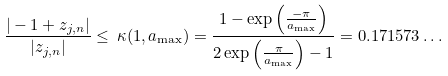Convert formula to latex. <formula><loc_0><loc_0><loc_500><loc_500>\frac { | - 1 + z _ { j , n } | } { | z _ { j , n } | } \leq \, \kappa ( 1 , a _ { \max } ) = \frac { 1 - \exp \left ( \frac { - \pi } { a _ { \max } } \right ) } { 2 \exp \left ( \frac { \pi } { a _ { \max } } \right ) - 1 } = 0 . 1 7 1 5 7 3 \dots</formula> 